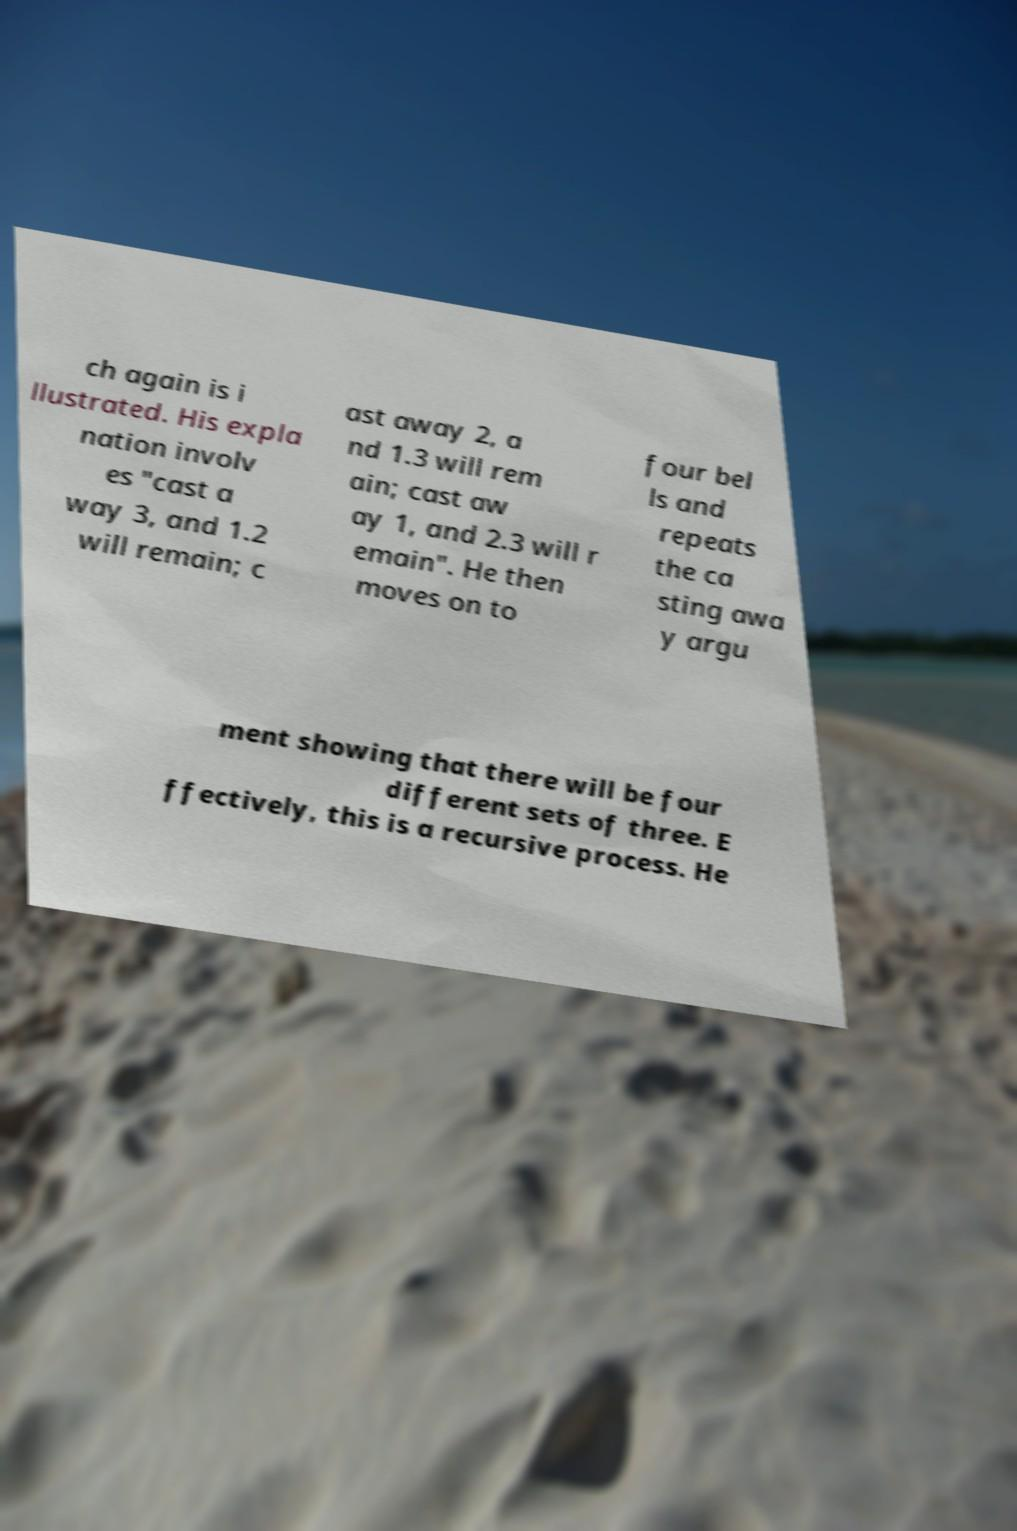Can you accurately transcribe the text from the provided image for me? ch again is i llustrated. His expla nation involv es "cast a way 3, and 1.2 will remain; c ast away 2, a nd 1.3 will rem ain; cast aw ay 1, and 2.3 will r emain". He then moves on to four bel ls and repeats the ca sting awa y argu ment showing that there will be four different sets of three. E ffectively, this is a recursive process. He 